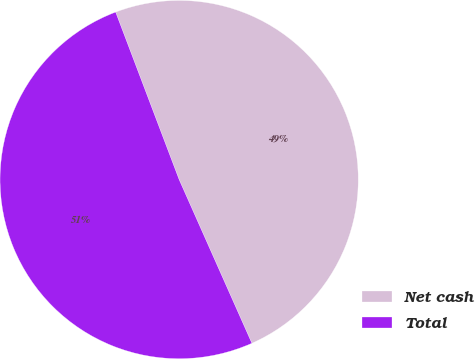Convert chart. <chart><loc_0><loc_0><loc_500><loc_500><pie_chart><fcel>Net cash<fcel>Total<nl><fcel>49.11%<fcel>50.89%<nl></chart> 